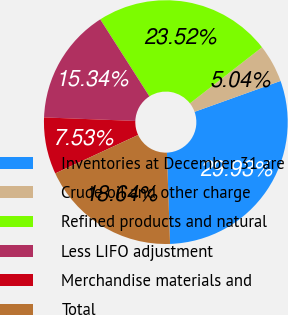Convert chart. <chart><loc_0><loc_0><loc_500><loc_500><pie_chart><fcel>Inventories at December 31 are<fcel>Crude oil and other charge<fcel>Refined products and natural<fcel>Less LIFO adjustment<fcel>Merchandise materials and<fcel>Total<nl><fcel>29.93%<fcel>5.04%<fcel>23.52%<fcel>15.34%<fcel>7.53%<fcel>18.64%<nl></chart> 